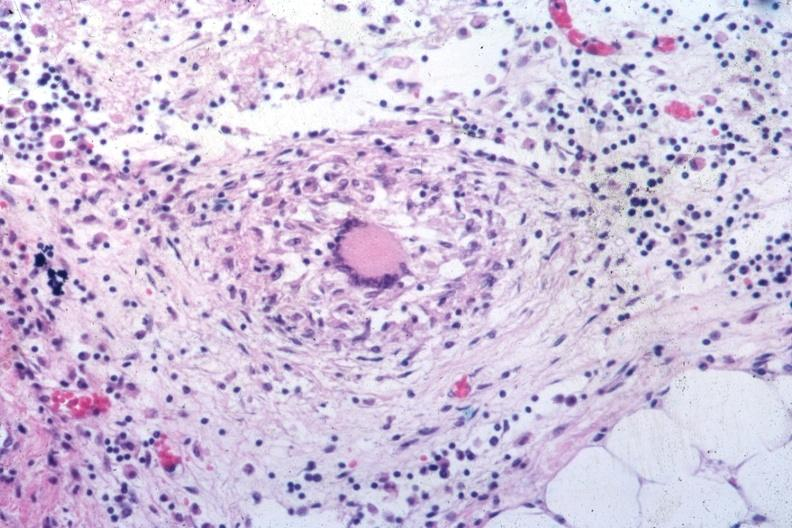what is outstanding example of a tubercular granuloma same as in slide seen?
Answer the question using a single word or phrase. At low classical with langhans giant cell 